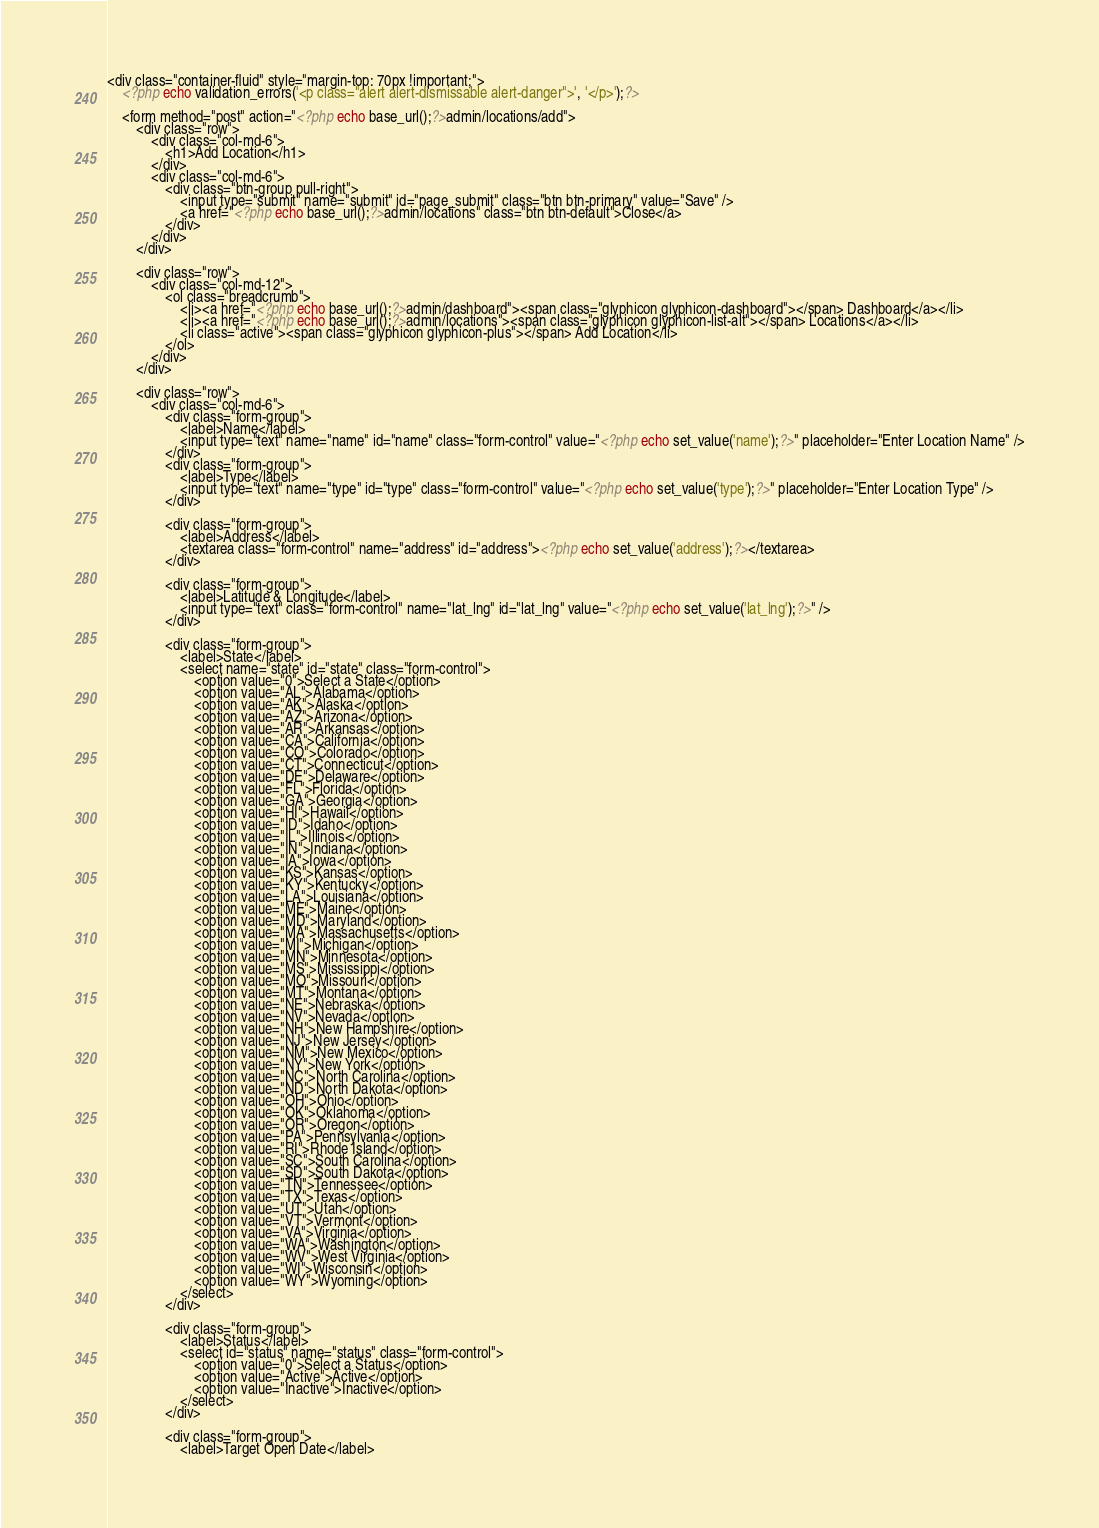Convert code to text. <code><loc_0><loc_0><loc_500><loc_500><_PHP_><div class="container-fluid" style="margin-top: 70px !important;">
    <?php echo validation_errors('<p class="alert alert-dismissable alert-danger">', '</p>');?>
    
    <form method="post" action="<?php echo base_url();?>admin/locations/add">
        <div class="row">
            <div class="col-md-6">
                <h1>Add Location</h1>
            </div>
            <div class="col-md-6">
                <div class="btn-group pull-right">
                    <input type="submit" name="submit" id="page_submit" class="btn btn-primary" value="Save" />
                    <a href="<?php echo base_url();?>admin/locations" class="btn btn-default">Close</a>
                </div>
            </div>
        </div>
        
        <div class="row">
            <div class="col-md-12">
                <ol class="breadcrumb">
                    <li><a href="<?php echo base_url();?>admin/dashboard"><span class="glyphicon glyphicon-dashboard"></span> Dashboard</a></li>
                    <li><a href="<?php echo base_url();?>admin/locations"><span class="glyphicon glyphicon-list-alt"></span> Locations</a></li>
                    <li class="active"><span class="glyphicon glyphicon-plus"></span> Add Location</li>
                </ol>
            </div>
        </div>
        
        <div class="row">
            <div class="col-md-6">
                <div class="form-group">
                    <label>Name</label>
                    <input type="text" name="name" id="name" class="form-control" value="<?php echo set_value('name');?>" placeholder="Enter Location Name" />
                </div>
                <div class="form-group">
                    <label>Type</label>
                    <input type="text" name="type" id="type" class="form-control" value="<?php echo set_value('type');?>" placeholder="Enter Location Type" />
                </div>
                
                <div class="form-group">
                    <label>Address</label>
                    <textarea class="form-control" name="address" id="address"><?php echo set_value('address');?></textarea>
                </div>
                
                <div class="form-group">
                    <label>Latitude & Longitude</label>
                    <input type="text" class="form-control" name="lat_lng" id="lat_lng" value="<?php echo set_value('lat_lng');?>" />
                </div>
                
                <div class="form-group">
                    <label>State</label>
                    <select name="state" id="state" class="form-control">
                        <option value="0">Select a State</option>
                        <option value="AL">Alabama</option>
                        <option value="AK">Alaska</option>
                        <option value="AZ">Arizona</option>
                        <option value="AR">Arkansas</option>
                        <option value="CA">California</option>
                        <option value="CO">Colorado</option>
                        <option value="CT">Connecticut</option>
                        <option value="DE">Delaware</option>
                        <option value="FL">Florida</option>
                        <option value="GA">Georgia</option>
                        <option value="HI">Hawaii</option>
                        <option value="ID">Idaho</option>
                        <option value="IL">Illinois</option>
                        <option value="IN">Indiana</option>
                        <option value="IA">Iowa</option>
                        <option value="KS">Kansas</option>
                        <option value="KY">Kentucky</option>
                        <option value="LA">Louisiana</option>
                        <option value="ME">Maine</option>
                        <option value="MD">Maryland</option>
                        <option value="MA">Massachusetts</option>
                        <option value="MI">Michigan</option>
                        <option value="MN">Minnesota</option>
                        <option value="MS">Mississippi</option>
                        <option value="MO">Missouri</option>
                        <option value="MT">Montana</option>
                        <option value="NE">Nebraska</option>
                        <option value="NV">Nevada</option>
                        <option value="NH">New Hampshire</option>
                        <option value="NJ">New Jersey</option>
                        <option value="NM">New Mexico</option>
                        <option value="NY">New York</option>
                        <option value="NC">North Carolina</option>
                        <option value="ND">North Dakota</option>
                        <option value="OH">Ohio</option>
                        <option value="OK">Oklahoma</option>
                        <option value="OR">Oregon</option>
                        <option value="PA">Pennsylvania</option>
                        <option value="RI">Rhode Island</option>
                        <option value="SC">South Carolina</option>
                        <option value="SD">South Dakota</option>
                        <option value="TN">Tennessee</option>
                        <option value="TX">Texas</option>
                        <option value="UT">Utah</option>
                        <option value="VT">Vermont</option>
                        <option value="VA">Virginia</option>
                        <option value="WA">Washington</option>
                        <option value="WV">West Virginia</option>
                        <option value="WI">Wisconsin</option>
                        <option value="WY">Wyoming</option>
                    </select>
                </div>

                <div class="form-group">
                    <label>Status</label>
                    <select id="status" name="status" class="form-control">
                        <option value="0">Select a Status</option>
                        <option value="Active">Active</option>
                        <option value="Inactive">Inactive</option>
                    </select>
                </div>

                <div class="form-group">
                    <label>Target Open Date</label></code> 